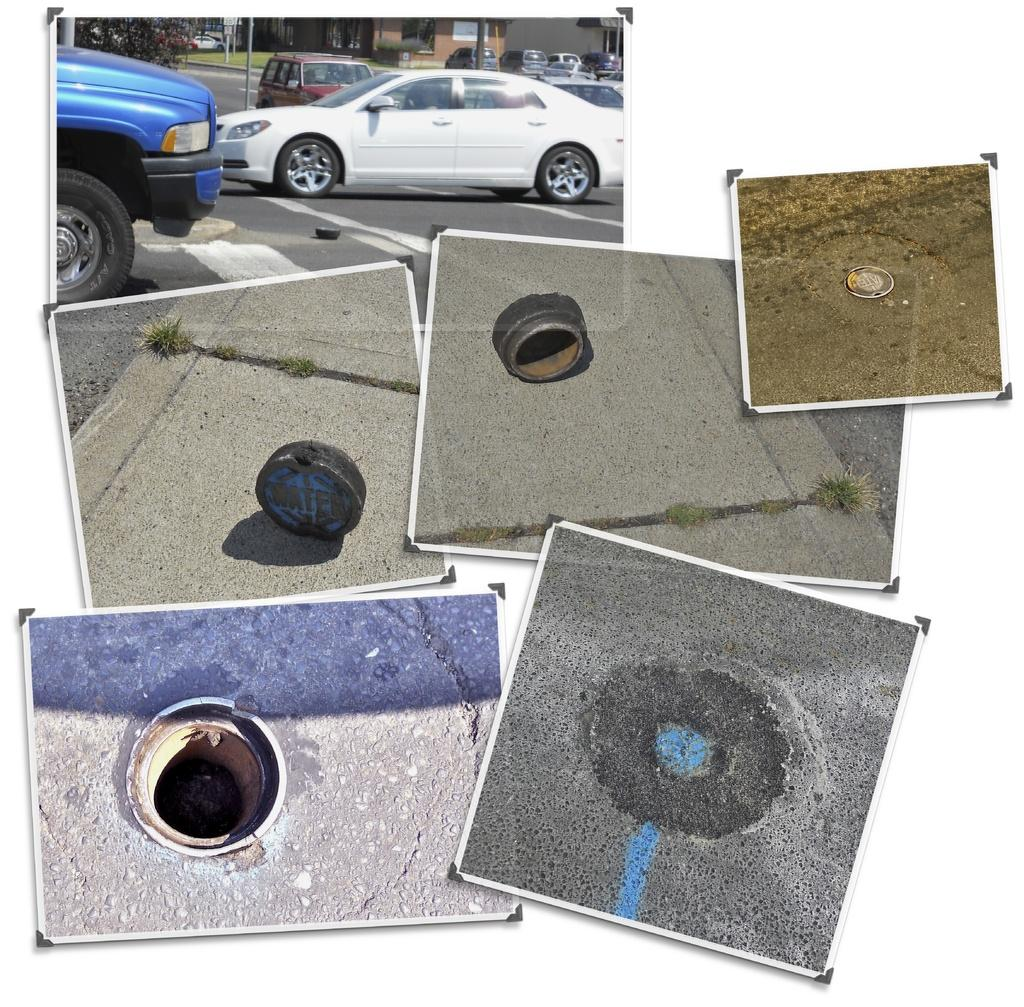What type of vehicles can be seen on the road in the image? There are cars on the road in the image. Are there any cars that are not moving in the image? Yes, there are parked cars in the image. What structures can be seen in the image? There are buildings visible in the image. What type of plant is present in the image? There is a tree in the image. What type of utility feature is present in the image? A manhole is present in the image, and the manhole cap is visible. Is there any indication of a manhole being opened in the image? Yes, there is a picture of an opened manhole in the image. What scent can be detected coming from the tree in the image? There is no information about the scent of the tree in the image, and therefore it cannot be determined. Is there a boy visible in the image? There is no mention of a boy in the provided facts, and therefore it cannot be determined if a boy is present in the image. 